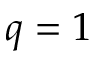<formula> <loc_0><loc_0><loc_500><loc_500>q = 1</formula> 